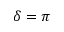Convert formula to latex. <formula><loc_0><loc_0><loc_500><loc_500>\delta = \pi</formula> 